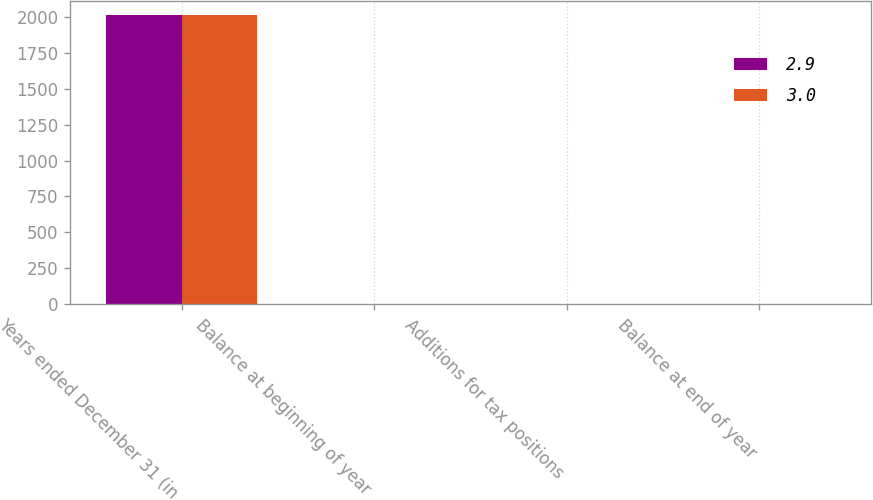Convert chart to OTSL. <chart><loc_0><loc_0><loc_500><loc_500><stacked_bar_chart><ecel><fcel>Years ended December 31 (in<fcel>Balance at beginning of year<fcel>Additions for tax positions<fcel>Balance at end of year<nl><fcel>2.9<fcel>2013<fcel>2.9<fcel>0.1<fcel>3<nl><fcel>3<fcel>2012<fcel>3<fcel>0.4<fcel>2.9<nl></chart> 